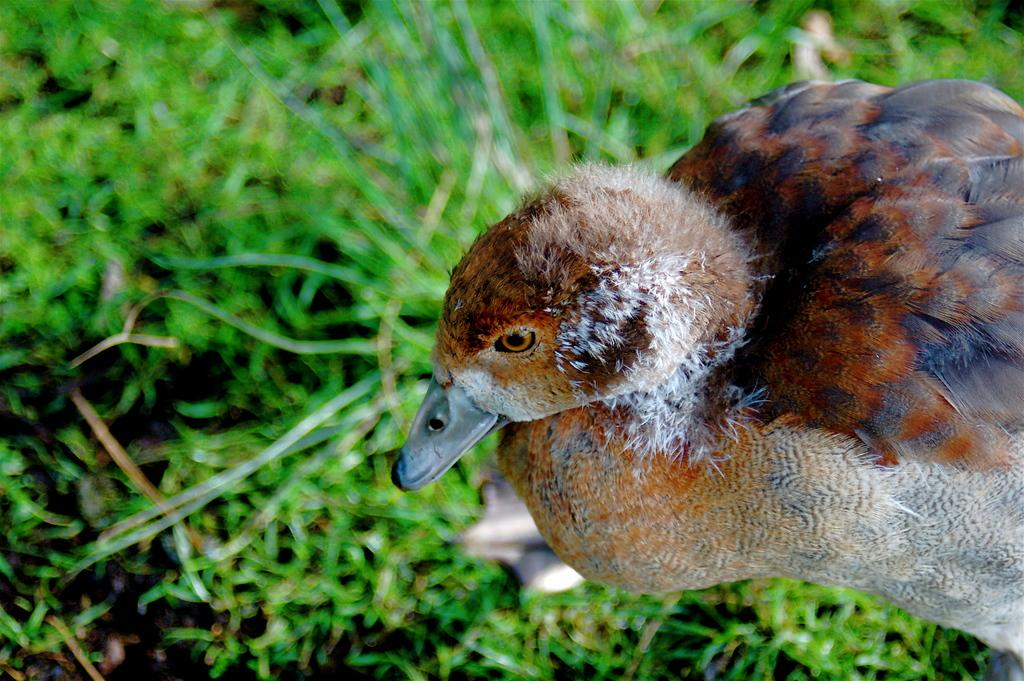What animal can be seen in the image? There is a duck in the image. Where is the duck located? The duck is standing on a grass field. How does the duck express its feelings in the image? The image does not depict the duck's feelings, so we cannot determine how it expresses them. 